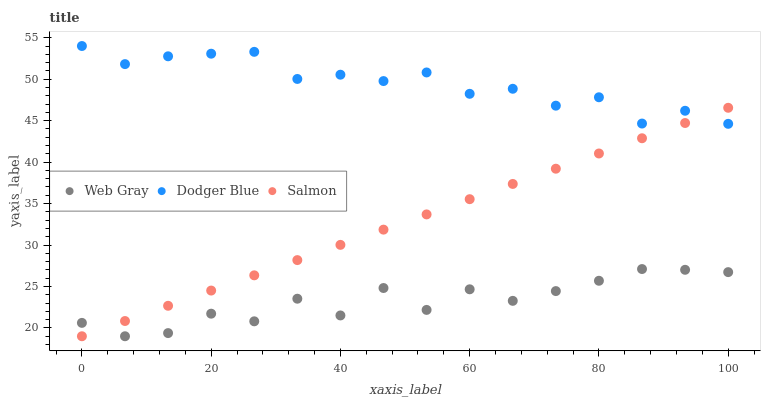Does Web Gray have the minimum area under the curve?
Answer yes or no. Yes. Does Dodger Blue have the maximum area under the curve?
Answer yes or no. Yes. Does Dodger Blue have the minimum area under the curve?
Answer yes or no. No. Does Web Gray have the maximum area under the curve?
Answer yes or no. No. Is Salmon the smoothest?
Answer yes or no. Yes. Is Web Gray the roughest?
Answer yes or no. Yes. Is Dodger Blue the smoothest?
Answer yes or no. No. Is Dodger Blue the roughest?
Answer yes or no. No. Does Salmon have the lowest value?
Answer yes or no. Yes. Does Dodger Blue have the lowest value?
Answer yes or no. No. Does Dodger Blue have the highest value?
Answer yes or no. Yes. Does Web Gray have the highest value?
Answer yes or no. No. Is Web Gray less than Dodger Blue?
Answer yes or no. Yes. Is Dodger Blue greater than Web Gray?
Answer yes or no. Yes. Does Dodger Blue intersect Salmon?
Answer yes or no. Yes. Is Dodger Blue less than Salmon?
Answer yes or no. No. Is Dodger Blue greater than Salmon?
Answer yes or no. No. Does Web Gray intersect Dodger Blue?
Answer yes or no. No. 